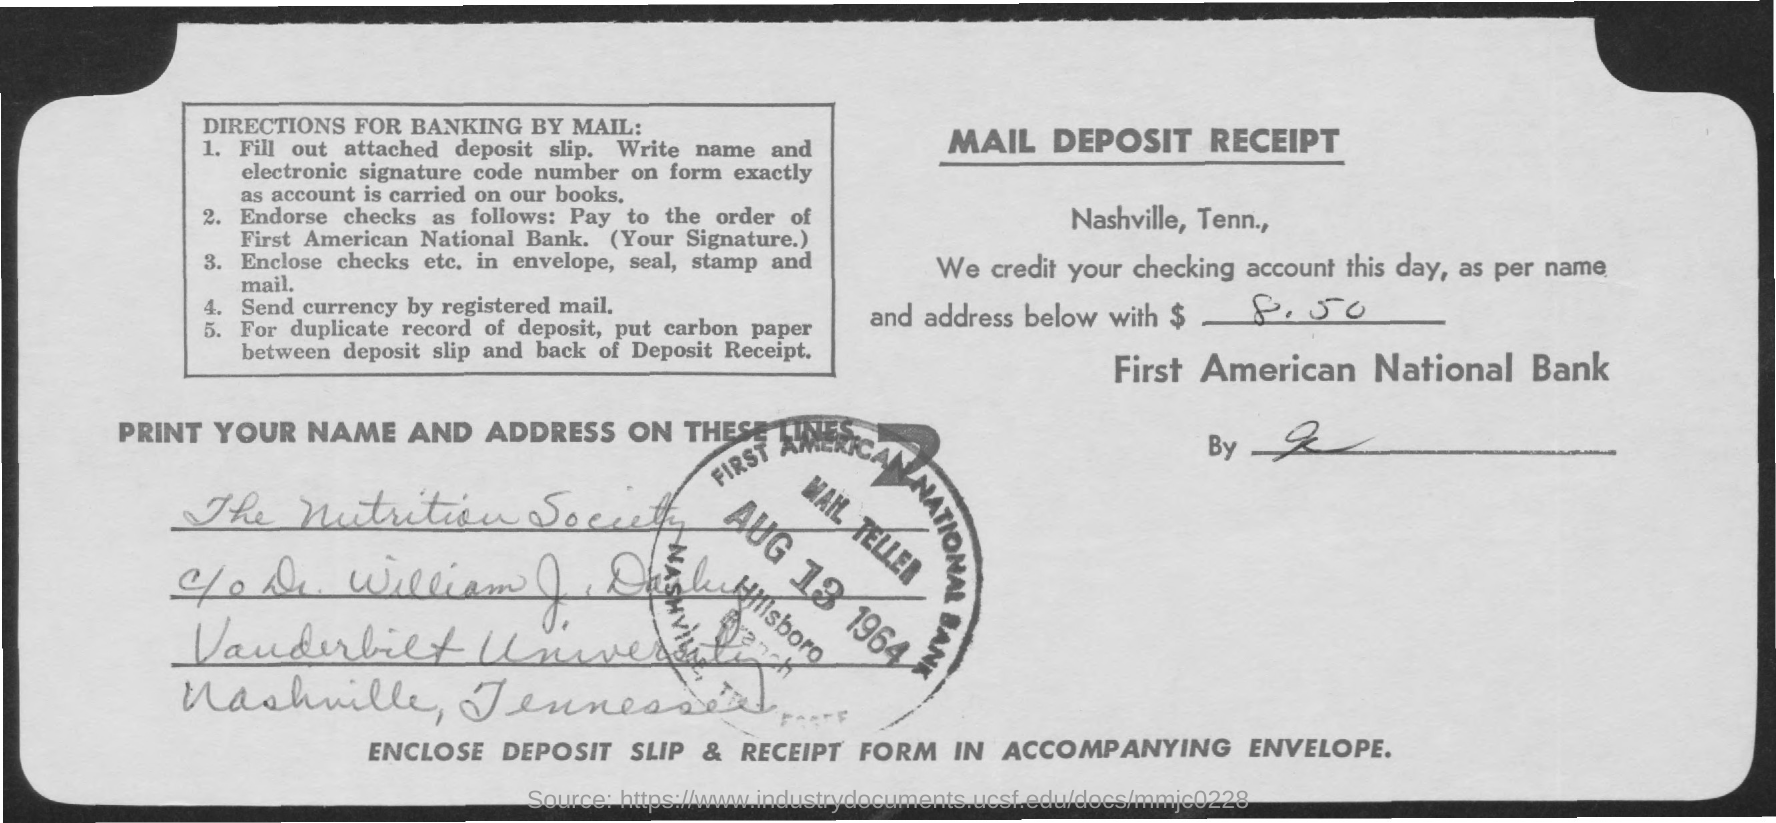Highlight a few significant elements in this photo. The amount has been credited to First American National Bank. According to the instructions for banking by mail as outlined in 'DIRECTIONS FOR BANKING BY MAIL:', the term 'currency' requires to be sent via registered mail. The date on the seal is August 13, 1964. Vanderbilt University is mentioned in the address. This is a mail deposit receipt. 